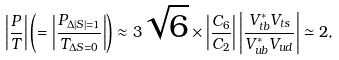Convert formula to latex. <formula><loc_0><loc_0><loc_500><loc_500>\left | \frac { P } { T } \right | \left ( = \left | \frac { P _ { \Delta | S | = 1 } } { T _ { \Delta S = 0 } } \right | \right ) \approx 3 \sqrt { 6 } \times \left | \frac { C _ { 6 } } { C _ { 2 } } \right | \left | \frac { V ^ { * } _ { t b } V _ { t s } } { V ^ { * } _ { u b } V _ { u d } } \right | \simeq 2 ,</formula> 